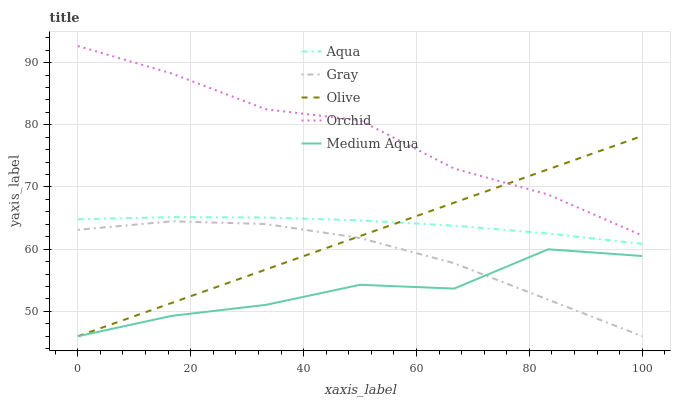Does Medium Aqua have the minimum area under the curve?
Answer yes or no. Yes. Does Orchid have the maximum area under the curve?
Answer yes or no. Yes. Does Gray have the minimum area under the curve?
Answer yes or no. No. Does Gray have the maximum area under the curve?
Answer yes or no. No. Is Olive the smoothest?
Answer yes or no. Yes. Is Medium Aqua the roughest?
Answer yes or no. Yes. Is Gray the smoothest?
Answer yes or no. No. Is Gray the roughest?
Answer yes or no. No. Does Olive have the lowest value?
Answer yes or no. Yes. Does Aqua have the lowest value?
Answer yes or no. No. Does Orchid have the highest value?
Answer yes or no. Yes. Does Gray have the highest value?
Answer yes or no. No. Is Aqua less than Orchid?
Answer yes or no. Yes. Is Aqua greater than Gray?
Answer yes or no. Yes. Does Orchid intersect Olive?
Answer yes or no. Yes. Is Orchid less than Olive?
Answer yes or no. No. Is Orchid greater than Olive?
Answer yes or no. No. Does Aqua intersect Orchid?
Answer yes or no. No. 